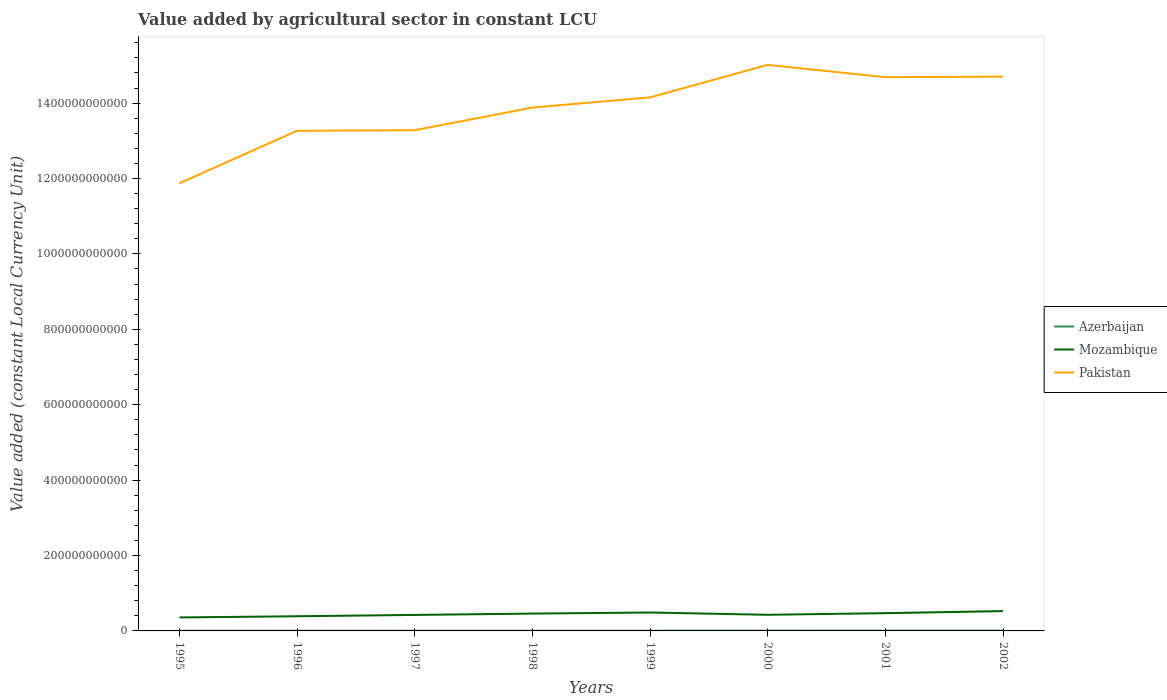How many different coloured lines are there?
Ensure brevity in your answer.  3. Does the line corresponding to Mozambique intersect with the line corresponding to Pakistan?
Give a very brief answer. No. Is the number of lines equal to the number of legend labels?
Give a very brief answer. Yes. Across all years, what is the maximum value added by agricultural sector in Azerbaijan?
Keep it short and to the point. 5.58e+08. What is the total value added by agricultural sector in Pakistan in the graph?
Your answer should be very brief. -1.42e+11. What is the difference between the highest and the second highest value added by agricultural sector in Mozambique?
Your answer should be very brief. 1.68e+1. Is the value added by agricultural sector in Mozambique strictly greater than the value added by agricultural sector in Pakistan over the years?
Give a very brief answer. Yes. How many lines are there?
Ensure brevity in your answer.  3. What is the difference between two consecutive major ticks on the Y-axis?
Make the answer very short. 2.00e+11. Are the values on the major ticks of Y-axis written in scientific E-notation?
Your answer should be compact. No. Does the graph contain any zero values?
Provide a short and direct response. No. Does the graph contain grids?
Your answer should be very brief. No. How are the legend labels stacked?
Your answer should be very brief. Vertical. What is the title of the graph?
Give a very brief answer. Value added by agricultural sector in constant LCU. Does "Arab World" appear as one of the legend labels in the graph?
Ensure brevity in your answer.  No. What is the label or title of the Y-axis?
Offer a very short reply. Value added (constant Local Currency Unit). What is the Value added (constant Local Currency Unit) of Azerbaijan in 1995?
Provide a succinct answer. 5.82e+08. What is the Value added (constant Local Currency Unit) in Mozambique in 1995?
Offer a very short reply. 3.58e+1. What is the Value added (constant Local Currency Unit) in Pakistan in 1995?
Provide a short and direct response. 1.19e+12. What is the Value added (constant Local Currency Unit) in Azerbaijan in 1996?
Give a very brief answer. 5.99e+08. What is the Value added (constant Local Currency Unit) of Mozambique in 1996?
Make the answer very short. 3.89e+1. What is the Value added (constant Local Currency Unit) in Pakistan in 1996?
Provide a short and direct response. 1.33e+12. What is the Value added (constant Local Currency Unit) in Azerbaijan in 1997?
Offer a terse response. 5.58e+08. What is the Value added (constant Local Currency Unit) of Mozambique in 1997?
Ensure brevity in your answer.  4.24e+1. What is the Value added (constant Local Currency Unit) of Pakistan in 1997?
Your response must be concise. 1.33e+12. What is the Value added (constant Local Currency Unit) of Azerbaijan in 1998?
Keep it short and to the point. 5.93e+08. What is the Value added (constant Local Currency Unit) in Mozambique in 1998?
Make the answer very short. 4.60e+1. What is the Value added (constant Local Currency Unit) in Pakistan in 1998?
Make the answer very short. 1.39e+12. What is the Value added (constant Local Currency Unit) in Azerbaijan in 1999?
Offer a very short reply. 6.35e+08. What is the Value added (constant Local Currency Unit) in Mozambique in 1999?
Your answer should be compact. 4.88e+1. What is the Value added (constant Local Currency Unit) in Pakistan in 1999?
Provide a succinct answer. 1.42e+12. What is the Value added (constant Local Currency Unit) in Azerbaijan in 2000?
Make the answer very short. 7.59e+08. What is the Value added (constant Local Currency Unit) of Mozambique in 2000?
Your answer should be very brief. 4.28e+1. What is the Value added (constant Local Currency Unit) of Pakistan in 2000?
Offer a very short reply. 1.50e+12. What is the Value added (constant Local Currency Unit) in Azerbaijan in 2001?
Your answer should be very brief. 8.43e+08. What is the Value added (constant Local Currency Unit) in Mozambique in 2001?
Ensure brevity in your answer.  4.71e+1. What is the Value added (constant Local Currency Unit) of Pakistan in 2001?
Your answer should be very brief. 1.47e+12. What is the Value added (constant Local Currency Unit) of Azerbaijan in 2002?
Offer a very short reply. 8.97e+08. What is the Value added (constant Local Currency Unit) of Mozambique in 2002?
Provide a succinct answer. 5.26e+1. What is the Value added (constant Local Currency Unit) in Pakistan in 2002?
Offer a terse response. 1.47e+12. Across all years, what is the maximum Value added (constant Local Currency Unit) of Azerbaijan?
Provide a succinct answer. 8.97e+08. Across all years, what is the maximum Value added (constant Local Currency Unit) of Mozambique?
Provide a succinct answer. 5.26e+1. Across all years, what is the maximum Value added (constant Local Currency Unit) of Pakistan?
Your answer should be very brief. 1.50e+12. Across all years, what is the minimum Value added (constant Local Currency Unit) in Azerbaijan?
Offer a terse response. 5.58e+08. Across all years, what is the minimum Value added (constant Local Currency Unit) of Mozambique?
Your answer should be very brief. 3.58e+1. Across all years, what is the minimum Value added (constant Local Currency Unit) of Pakistan?
Offer a terse response. 1.19e+12. What is the total Value added (constant Local Currency Unit) of Azerbaijan in the graph?
Offer a terse response. 5.47e+09. What is the total Value added (constant Local Currency Unit) of Mozambique in the graph?
Ensure brevity in your answer.  3.54e+11. What is the total Value added (constant Local Currency Unit) of Pakistan in the graph?
Give a very brief answer. 1.11e+13. What is the difference between the Value added (constant Local Currency Unit) in Azerbaijan in 1995 and that in 1996?
Keep it short and to the point. -1.75e+07. What is the difference between the Value added (constant Local Currency Unit) of Mozambique in 1995 and that in 1996?
Your answer should be very brief. -3.13e+09. What is the difference between the Value added (constant Local Currency Unit) of Pakistan in 1995 and that in 1996?
Give a very brief answer. -1.39e+11. What is the difference between the Value added (constant Local Currency Unit) in Azerbaijan in 1995 and that in 1997?
Give a very brief answer. 2.39e+07. What is the difference between the Value added (constant Local Currency Unit) in Mozambique in 1995 and that in 1997?
Offer a very short reply. -6.67e+09. What is the difference between the Value added (constant Local Currency Unit) in Pakistan in 1995 and that in 1997?
Your answer should be very brief. -1.41e+11. What is the difference between the Value added (constant Local Currency Unit) in Azerbaijan in 1995 and that in 1998?
Keep it short and to the point. -1.07e+07. What is the difference between the Value added (constant Local Currency Unit) in Mozambique in 1995 and that in 1998?
Make the answer very short. -1.02e+1. What is the difference between the Value added (constant Local Currency Unit) of Pakistan in 1995 and that in 1998?
Your answer should be compact. -2.01e+11. What is the difference between the Value added (constant Local Currency Unit) of Azerbaijan in 1995 and that in 1999?
Give a very brief answer. -5.28e+07. What is the difference between the Value added (constant Local Currency Unit) in Mozambique in 1995 and that in 1999?
Give a very brief answer. -1.31e+1. What is the difference between the Value added (constant Local Currency Unit) in Pakistan in 1995 and that in 1999?
Give a very brief answer. -2.28e+11. What is the difference between the Value added (constant Local Currency Unit) in Azerbaijan in 1995 and that in 2000?
Make the answer very short. -1.77e+08. What is the difference between the Value added (constant Local Currency Unit) in Mozambique in 1995 and that in 2000?
Ensure brevity in your answer.  -7.01e+09. What is the difference between the Value added (constant Local Currency Unit) of Pakistan in 1995 and that in 2000?
Make the answer very short. -3.14e+11. What is the difference between the Value added (constant Local Currency Unit) in Azerbaijan in 1995 and that in 2001?
Make the answer very short. -2.61e+08. What is the difference between the Value added (constant Local Currency Unit) of Mozambique in 1995 and that in 2001?
Give a very brief answer. -1.13e+1. What is the difference between the Value added (constant Local Currency Unit) of Pakistan in 1995 and that in 2001?
Make the answer very short. -2.81e+11. What is the difference between the Value added (constant Local Currency Unit) of Azerbaijan in 1995 and that in 2002?
Your answer should be very brief. -3.15e+08. What is the difference between the Value added (constant Local Currency Unit) of Mozambique in 1995 and that in 2002?
Your answer should be compact. -1.68e+1. What is the difference between the Value added (constant Local Currency Unit) of Pakistan in 1995 and that in 2002?
Offer a very short reply. -2.83e+11. What is the difference between the Value added (constant Local Currency Unit) in Azerbaijan in 1996 and that in 1997?
Offer a terse response. 4.14e+07. What is the difference between the Value added (constant Local Currency Unit) of Mozambique in 1996 and that in 1997?
Make the answer very short. -3.54e+09. What is the difference between the Value added (constant Local Currency Unit) of Pakistan in 1996 and that in 1997?
Your response must be concise. -1.64e+09. What is the difference between the Value added (constant Local Currency Unit) in Azerbaijan in 1996 and that in 1998?
Give a very brief answer. 6.76e+06. What is the difference between the Value added (constant Local Currency Unit) of Mozambique in 1996 and that in 1998?
Provide a short and direct response. -7.11e+09. What is the difference between the Value added (constant Local Currency Unit) in Pakistan in 1996 and that in 1998?
Offer a terse response. -6.16e+1. What is the difference between the Value added (constant Local Currency Unit) in Azerbaijan in 1996 and that in 1999?
Provide a short and direct response. -3.53e+07. What is the difference between the Value added (constant Local Currency Unit) of Mozambique in 1996 and that in 1999?
Make the answer very short. -9.93e+09. What is the difference between the Value added (constant Local Currency Unit) of Pakistan in 1996 and that in 1999?
Your response must be concise. -8.87e+1. What is the difference between the Value added (constant Local Currency Unit) in Azerbaijan in 1996 and that in 2000?
Provide a succinct answer. -1.60e+08. What is the difference between the Value added (constant Local Currency Unit) of Mozambique in 1996 and that in 2000?
Give a very brief answer. -3.88e+09. What is the difference between the Value added (constant Local Currency Unit) of Pakistan in 1996 and that in 2000?
Offer a terse response. -1.75e+11. What is the difference between the Value added (constant Local Currency Unit) of Azerbaijan in 1996 and that in 2001?
Offer a very short reply. -2.44e+08. What is the difference between the Value added (constant Local Currency Unit) in Mozambique in 1996 and that in 2001?
Make the answer very short. -8.22e+09. What is the difference between the Value added (constant Local Currency Unit) in Pakistan in 1996 and that in 2001?
Make the answer very short. -1.42e+11. What is the difference between the Value added (constant Local Currency Unit) of Azerbaijan in 1996 and that in 2002?
Your answer should be very brief. -2.98e+08. What is the difference between the Value added (constant Local Currency Unit) of Mozambique in 1996 and that in 2002?
Ensure brevity in your answer.  -1.37e+1. What is the difference between the Value added (constant Local Currency Unit) of Pakistan in 1996 and that in 2002?
Offer a very short reply. -1.44e+11. What is the difference between the Value added (constant Local Currency Unit) in Azerbaijan in 1997 and that in 1998?
Keep it short and to the point. -3.46e+07. What is the difference between the Value added (constant Local Currency Unit) in Mozambique in 1997 and that in 1998?
Your answer should be compact. -3.57e+09. What is the difference between the Value added (constant Local Currency Unit) in Pakistan in 1997 and that in 1998?
Give a very brief answer. -6.00e+1. What is the difference between the Value added (constant Local Currency Unit) in Azerbaijan in 1997 and that in 1999?
Keep it short and to the point. -7.67e+07. What is the difference between the Value added (constant Local Currency Unit) in Mozambique in 1997 and that in 1999?
Ensure brevity in your answer.  -6.39e+09. What is the difference between the Value added (constant Local Currency Unit) in Pakistan in 1997 and that in 1999?
Your answer should be very brief. -8.71e+1. What is the difference between the Value added (constant Local Currency Unit) in Azerbaijan in 1997 and that in 2000?
Give a very brief answer. -2.01e+08. What is the difference between the Value added (constant Local Currency Unit) of Mozambique in 1997 and that in 2000?
Provide a succinct answer. -3.44e+08. What is the difference between the Value added (constant Local Currency Unit) of Pakistan in 1997 and that in 2000?
Keep it short and to the point. -1.73e+11. What is the difference between the Value added (constant Local Currency Unit) of Azerbaijan in 1997 and that in 2001?
Ensure brevity in your answer.  -2.85e+08. What is the difference between the Value added (constant Local Currency Unit) of Mozambique in 1997 and that in 2001?
Ensure brevity in your answer.  -4.68e+09. What is the difference between the Value added (constant Local Currency Unit) of Pakistan in 1997 and that in 2001?
Provide a succinct answer. -1.41e+11. What is the difference between the Value added (constant Local Currency Unit) of Azerbaijan in 1997 and that in 2002?
Provide a succinct answer. -3.39e+08. What is the difference between the Value added (constant Local Currency Unit) in Mozambique in 1997 and that in 2002?
Keep it short and to the point. -1.01e+1. What is the difference between the Value added (constant Local Currency Unit) in Pakistan in 1997 and that in 2002?
Provide a short and direct response. -1.42e+11. What is the difference between the Value added (constant Local Currency Unit) in Azerbaijan in 1998 and that in 1999?
Give a very brief answer. -4.21e+07. What is the difference between the Value added (constant Local Currency Unit) of Mozambique in 1998 and that in 1999?
Offer a terse response. -2.82e+09. What is the difference between the Value added (constant Local Currency Unit) of Pakistan in 1998 and that in 1999?
Keep it short and to the point. -2.71e+1. What is the difference between the Value added (constant Local Currency Unit) of Azerbaijan in 1998 and that in 2000?
Your response must be concise. -1.66e+08. What is the difference between the Value added (constant Local Currency Unit) of Mozambique in 1998 and that in 2000?
Your response must be concise. 3.23e+09. What is the difference between the Value added (constant Local Currency Unit) of Pakistan in 1998 and that in 2000?
Provide a succinct answer. -1.13e+11. What is the difference between the Value added (constant Local Currency Unit) of Azerbaijan in 1998 and that in 2001?
Ensure brevity in your answer.  -2.51e+08. What is the difference between the Value added (constant Local Currency Unit) of Mozambique in 1998 and that in 2001?
Your response must be concise. -1.11e+09. What is the difference between the Value added (constant Local Currency Unit) of Pakistan in 1998 and that in 2001?
Ensure brevity in your answer.  -8.06e+1. What is the difference between the Value added (constant Local Currency Unit) in Azerbaijan in 1998 and that in 2002?
Ensure brevity in your answer.  -3.05e+08. What is the difference between the Value added (constant Local Currency Unit) of Mozambique in 1998 and that in 2002?
Provide a short and direct response. -6.56e+09. What is the difference between the Value added (constant Local Currency Unit) in Pakistan in 1998 and that in 2002?
Give a very brief answer. -8.21e+1. What is the difference between the Value added (constant Local Currency Unit) in Azerbaijan in 1999 and that in 2000?
Give a very brief answer. -1.24e+08. What is the difference between the Value added (constant Local Currency Unit) of Mozambique in 1999 and that in 2000?
Offer a terse response. 6.05e+09. What is the difference between the Value added (constant Local Currency Unit) of Pakistan in 1999 and that in 2000?
Offer a terse response. -8.62e+1. What is the difference between the Value added (constant Local Currency Unit) of Azerbaijan in 1999 and that in 2001?
Make the answer very short. -2.09e+08. What is the difference between the Value added (constant Local Currency Unit) in Mozambique in 1999 and that in 2001?
Keep it short and to the point. 1.71e+09. What is the difference between the Value added (constant Local Currency Unit) in Pakistan in 1999 and that in 2001?
Ensure brevity in your answer.  -5.35e+1. What is the difference between the Value added (constant Local Currency Unit) in Azerbaijan in 1999 and that in 2002?
Provide a succinct answer. -2.62e+08. What is the difference between the Value added (constant Local Currency Unit) of Mozambique in 1999 and that in 2002?
Your response must be concise. -3.74e+09. What is the difference between the Value added (constant Local Currency Unit) in Pakistan in 1999 and that in 2002?
Your response must be concise. -5.51e+1. What is the difference between the Value added (constant Local Currency Unit) in Azerbaijan in 2000 and that in 2001?
Offer a very short reply. -8.42e+07. What is the difference between the Value added (constant Local Currency Unit) of Mozambique in 2000 and that in 2001?
Make the answer very short. -4.33e+09. What is the difference between the Value added (constant Local Currency Unit) of Pakistan in 2000 and that in 2001?
Provide a short and direct response. 3.27e+1. What is the difference between the Value added (constant Local Currency Unit) in Azerbaijan in 2000 and that in 2002?
Provide a succinct answer. -1.38e+08. What is the difference between the Value added (constant Local Currency Unit) of Mozambique in 2000 and that in 2002?
Your answer should be compact. -9.79e+09. What is the difference between the Value added (constant Local Currency Unit) in Pakistan in 2000 and that in 2002?
Give a very brief answer. 3.12e+1. What is the difference between the Value added (constant Local Currency Unit) in Azerbaijan in 2001 and that in 2002?
Provide a succinct answer. -5.40e+07. What is the difference between the Value added (constant Local Currency Unit) in Mozambique in 2001 and that in 2002?
Provide a short and direct response. -5.46e+09. What is the difference between the Value added (constant Local Currency Unit) in Pakistan in 2001 and that in 2002?
Offer a very short reply. -1.52e+09. What is the difference between the Value added (constant Local Currency Unit) in Azerbaijan in 1995 and the Value added (constant Local Currency Unit) in Mozambique in 1996?
Ensure brevity in your answer.  -3.83e+1. What is the difference between the Value added (constant Local Currency Unit) of Azerbaijan in 1995 and the Value added (constant Local Currency Unit) of Pakistan in 1996?
Provide a succinct answer. -1.33e+12. What is the difference between the Value added (constant Local Currency Unit) in Mozambique in 1995 and the Value added (constant Local Currency Unit) in Pakistan in 1996?
Give a very brief answer. -1.29e+12. What is the difference between the Value added (constant Local Currency Unit) in Azerbaijan in 1995 and the Value added (constant Local Currency Unit) in Mozambique in 1997?
Your response must be concise. -4.19e+1. What is the difference between the Value added (constant Local Currency Unit) of Azerbaijan in 1995 and the Value added (constant Local Currency Unit) of Pakistan in 1997?
Your response must be concise. -1.33e+12. What is the difference between the Value added (constant Local Currency Unit) of Mozambique in 1995 and the Value added (constant Local Currency Unit) of Pakistan in 1997?
Give a very brief answer. -1.29e+12. What is the difference between the Value added (constant Local Currency Unit) in Azerbaijan in 1995 and the Value added (constant Local Currency Unit) in Mozambique in 1998?
Your answer should be compact. -4.54e+1. What is the difference between the Value added (constant Local Currency Unit) of Azerbaijan in 1995 and the Value added (constant Local Currency Unit) of Pakistan in 1998?
Make the answer very short. -1.39e+12. What is the difference between the Value added (constant Local Currency Unit) of Mozambique in 1995 and the Value added (constant Local Currency Unit) of Pakistan in 1998?
Offer a very short reply. -1.35e+12. What is the difference between the Value added (constant Local Currency Unit) of Azerbaijan in 1995 and the Value added (constant Local Currency Unit) of Mozambique in 1999?
Your response must be concise. -4.83e+1. What is the difference between the Value added (constant Local Currency Unit) of Azerbaijan in 1995 and the Value added (constant Local Currency Unit) of Pakistan in 1999?
Provide a succinct answer. -1.41e+12. What is the difference between the Value added (constant Local Currency Unit) in Mozambique in 1995 and the Value added (constant Local Currency Unit) in Pakistan in 1999?
Offer a terse response. -1.38e+12. What is the difference between the Value added (constant Local Currency Unit) in Azerbaijan in 1995 and the Value added (constant Local Currency Unit) in Mozambique in 2000?
Provide a succinct answer. -4.22e+1. What is the difference between the Value added (constant Local Currency Unit) of Azerbaijan in 1995 and the Value added (constant Local Currency Unit) of Pakistan in 2000?
Your answer should be compact. -1.50e+12. What is the difference between the Value added (constant Local Currency Unit) in Mozambique in 1995 and the Value added (constant Local Currency Unit) in Pakistan in 2000?
Your response must be concise. -1.47e+12. What is the difference between the Value added (constant Local Currency Unit) of Azerbaijan in 1995 and the Value added (constant Local Currency Unit) of Mozambique in 2001?
Your response must be concise. -4.65e+1. What is the difference between the Value added (constant Local Currency Unit) in Azerbaijan in 1995 and the Value added (constant Local Currency Unit) in Pakistan in 2001?
Your answer should be compact. -1.47e+12. What is the difference between the Value added (constant Local Currency Unit) in Mozambique in 1995 and the Value added (constant Local Currency Unit) in Pakistan in 2001?
Your answer should be very brief. -1.43e+12. What is the difference between the Value added (constant Local Currency Unit) in Azerbaijan in 1995 and the Value added (constant Local Currency Unit) in Mozambique in 2002?
Keep it short and to the point. -5.20e+1. What is the difference between the Value added (constant Local Currency Unit) of Azerbaijan in 1995 and the Value added (constant Local Currency Unit) of Pakistan in 2002?
Ensure brevity in your answer.  -1.47e+12. What is the difference between the Value added (constant Local Currency Unit) of Mozambique in 1995 and the Value added (constant Local Currency Unit) of Pakistan in 2002?
Ensure brevity in your answer.  -1.43e+12. What is the difference between the Value added (constant Local Currency Unit) in Azerbaijan in 1996 and the Value added (constant Local Currency Unit) in Mozambique in 1997?
Your response must be concise. -4.18e+1. What is the difference between the Value added (constant Local Currency Unit) in Azerbaijan in 1996 and the Value added (constant Local Currency Unit) in Pakistan in 1997?
Provide a succinct answer. -1.33e+12. What is the difference between the Value added (constant Local Currency Unit) of Mozambique in 1996 and the Value added (constant Local Currency Unit) of Pakistan in 1997?
Your answer should be very brief. -1.29e+12. What is the difference between the Value added (constant Local Currency Unit) in Azerbaijan in 1996 and the Value added (constant Local Currency Unit) in Mozambique in 1998?
Provide a short and direct response. -4.54e+1. What is the difference between the Value added (constant Local Currency Unit) of Azerbaijan in 1996 and the Value added (constant Local Currency Unit) of Pakistan in 1998?
Give a very brief answer. -1.39e+12. What is the difference between the Value added (constant Local Currency Unit) in Mozambique in 1996 and the Value added (constant Local Currency Unit) in Pakistan in 1998?
Offer a very short reply. -1.35e+12. What is the difference between the Value added (constant Local Currency Unit) of Azerbaijan in 1996 and the Value added (constant Local Currency Unit) of Mozambique in 1999?
Offer a very short reply. -4.82e+1. What is the difference between the Value added (constant Local Currency Unit) of Azerbaijan in 1996 and the Value added (constant Local Currency Unit) of Pakistan in 1999?
Give a very brief answer. -1.41e+12. What is the difference between the Value added (constant Local Currency Unit) in Mozambique in 1996 and the Value added (constant Local Currency Unit) in Pakistan in 1999?
Give a very brief answer. -1.38e+12. What is the difference between the Value added (constant Local Currency Unit) of Azerbaijan in 1996 and the Value added (constant Local Currency Unit) of Mozambique in 2000?
Your response must be concise. -4.22e+1. What is the difference between the Value added (constant Local Currency Unit) in Azerbaijan in 1996 and the Value added (constant Local Currency Unit) in Pakistan in 2000?
Your answer should be compact. -1.50e+12. What is the difference between the Value added (constant Local Currency Unit) of Mozambique in 1996 and the Value added (constant Local Currency Unit) of Pakistan in 2000?
Your response must be concise. -1.46e+12. What is the difference between the Value added (constant Local Currency Unit) in Azerbaijan in 1996 and the Value added (constant Local Currency Unit) in Mozambique in 2001?
Provide a short and direct response. -4.65e+1. What is the difference between the Value added (constant Local Currency Unit) of Azerbaijan in 1996 and the Value added (constant Local Currency Unit) of Pakistan in 2001?
Your answer should be compact. -1.47e+12. What is the difference between the Value added (constant Local Currency Unit) in Mozambique in 1996 and the Value added (constant Local Currency Unit) in Pakistan in 2001?
Ensure brevity in your answer.  -1.43e+12. What is the difference between the Value added (constant Local Currency Unit) in Azerbaijan in 1996 and the Value added (constant Local Currency Unit) in Mozambique in 2002?
Your response must be concise. -5.20e+1. What is the difference between the Value added (constant Local Currency Unit) of Azerbaijan in 1996 and the Value added (constant Local Currency Unit) of Pakistan in 2002?
Your answer should be compact. -1.47e+12. What is the difference between the Value added (constant Local Currency Unit) in Mozambique in 1996 and the Value added (constant Local Currency Unit) in Pakistan in 2002?
Give a very brief answer. -1.43e+12. What is the difference between the Value added (constant Local Currency Unit) in Azerbaijan in 1997 and the Value added (constant Local Currency Unit) in Mozambique in 1998?
Provide a short and direct response. -4.55e+1. What is the difference between the Value added (constant Local Currency Unit) of Azerbaijan in 1997 and the Value added (constant Local Currency Unit) of Pakistan in 1998?
Offer a terse response. -1.39e+12. What is the difference between the Value added (constant Local Currency Unit) in Mozambique in 1997 and the Value added (constant Local Currency Unit) in Pakistan in 1998?
Ensure brevity in your answer.  -1.35e+12. What is the difference between the Value added (constant Local Currency Unit) in Azerbaijan in 1997 and the Value added (constant Local Currency Unit) in Mozambique in 1999?
Provide a succinct answer. -4.83e+1. What is the difference between the Value added (constant Local Currency Unit) of Azerbaijan in 1997 and the Value added (constant Local Currency Unit) of Pakistan in 1999?
Offer a terse response. -1.41e+12. What is the difference between the Value added (constant Local Currency Unit) in Mozambique in 1997 and the Value added (constant Local Currency Unit) in Pakistan in 1999?
Make the answer very short. -1.37e+12. What is the difference between the Value added (constant Local Currency Unit) of Azerbaijan in 1997 and the Value added (constant Local Currency Unit) of Mozambique in 2000?
Make the answer very short. -4.22e+1. What is the difference between the Value added (constant Local Currency Unit) of Azerbaijan in 1997 and the Value added (constant Local Currency Unit) of Pakistan in 2000?
Your answer should be very brief. -1.50e+12. What is the difference between the Value added (constant Local Currency Unit) in Mozambique in 1997 and the Value added (constant Local Currency Unit) in Pakistan in 2000?
Provide a short and direct response. -1.46e+12. What is the difference between the Value added (constant Local Currency Unit) of Azerbaijan in 1997 and the Value added (constant Local Currency Unit) of Mozambique in 2001?
Ensure brevity in your answer.  -4.66e+1. What is the difference between the Value added (constant Local Currency Unit) in Azerbaijan in 1997 and the Value added (constant Local Currency Unit) in Pakistan in 2001?
Your answer should be compact. -1.47e+12. What is the difference between the Value added (constant Local Currency Unit) of Mozambique in 1997 and the Value added (constant Local Currency Unit) of Pakistan in 2001?
Make the answer very short. -1.43e+12. What is the difference between the Value added (constant Local Currency Unit) of Azerbaijan in 1997 and the Value added (constant Local Currency Unit) of Mozambique in 2002?
Your response must be concise. -5.20e+1. What is the difference between the Value added (constant Local Currency Unit) in Azerbaijan in 1997 and the Value added (constant Local Currency Unit) in Pakistan in 2002?
Offer a very short reply. -1.47e+12. What is the difference between the Value added (constant Local Currency Unit) in Mozambique in 1997 and the Value added (constant Local Currency Unit) in Pakistan in 2002?
Provide a short and direct response. -1.43e+12. What is the difference between the Value added (constant Local Currency Unit) in Azerbaijan in 1998 and the Value added (constant Local Currency Unit) in Mozambique in 1999?
Your answer should be compact. -4.82e+1. What is the difference between the Value added (constant Local Currency Unit) in Azerbaijan in 1998 and the Value added (constant Local Currency Unit) in Pakistan in 1999?
Give a very brief answer. -1.41e+12. What is the difference between the Value added (constant Local Currency Unit) in Mozambique in 1998 and the Value added (constant Local Currency Unit) in Pakistan in 1999?
Keep it short and to the point. -1.37e+12. What is the difference between the Value added (constant Local Currency Unit) in Azerbaijan in 1998 and the Value added (constant Local Currency Unit) in Mozambique in 2000?
Keep it short and to the point. -4.22e+1. What is the difference between the Value added (constant Local Currency Unit) of Azerbaijan in 1998 and the Value added (constant Local Currency Unit) of Pakistan in 2000?
Offer a terse response. -1.50e+12. What is the difference between the Value added (constant Local Currency Unit) in Mozambique in 1998 and the Value added (constant Local Currency Unit) in Pakistan in 2000?
Offer a terse response. -1.46e+12. What is the difference between the Value added (constant Local Currency Unit) in Azerbaijan in 1998 and the Value added (constant Local Currency Unit) in Mozambique in 2001?
Give a very brief answer. -4.65e+1. What is the difference between the Value added (constant Local Currency Unit) in Azerbaijan in 1998 and the Value added (constant Local Currency Unit) in Pakistan in 2001?
Your response must be concise. -1.47e+12. What is the difference between the Value added (constant Local Currency Unit) in Mozambique in 1998 and the Value added (constant Local Currency Unit) in Pakistan in 2001?
Offer a very short reply. -1.42e+12. What is the difference between the Value added (constant Local Currency Unit) in Azerbaijan in 1998 and the Value added (constant Local Currency Unit) in Mozambique in 2002?
Make the answer very short. -5.20e+1. What is the difference between the Value added (constant Local Currency Unit) of Azerbaijan in 1998 and the Value added (constant Local Currency Unit) of Pakistan in 2002?
Provide a succinct answer. -1.47e+12. What is the difference between the Value added (constant Local Currency Unit) in Mozambique in 1998 and the Value added (constant Local Currency Unit) in Pakistan in 2002?
Keep it short and to the point. -1.42e+12. What is the difference between the Value added (constant Local Currency Unit) in Azerbaijan in 1999 and the Value added (constant Local Currency Unit) in Mozambique in 2000?
Give a very brief answer. -4.22e+1. What is the difference between the Value added (constant Local Currency Unit) of Azerbaijan in 1999 and the Value added (constant Local Currency Unit) of Pakistan in 2000?
Make the answer very short. -1.50e+12. What is the difference between the Value added (constant Local Currency Unit) in Mozambique in 1999 and the Value added (constant Local Currency Unit) in Pakistan in 2000?
Provide a succinct answer. -1.45e+12. What is the difference between the Value added (constant Local Currency Unit) in Azerbaijan in 1999 and the Value added (constant Local Currency Unit) in Mozambique in 2001?
Make the answer very short. -4.65e+1. What is the difference between the Value added (constant Local Currency Unit) of Azerbaijan in 1999 and the Value added (constant Local Currency Unit) of Pakistan in 2001?
Ensure brevity in your answer.  -1.47e+12. What is the difference between the Value added (constant Local Currency Unit) in Mozambique in 1999 and the Value added (constant Local Currency Unit) in Pakistan in 2001?
Your answer should be compact. -1.42e+12. What is the difference between the Value added (constant Local Currency Unit) of Azerbaijan in 1999 and the Value added (constant Local Currency Unit) of Mozambique in 2002?
Provide a succinct answer. -5.19e+1. What is the difference between the Value added (constant Local Currency Unit) in Azerbaijan in 1999 and the Value added (constant Local Currency Unit) in Pakistan in 2002?
Offer a terse response. -1.47e+12. What is the difference between the Value added (constant Local Currency Unit) in Mozambique in 1999 and the Value added (constant Local Currency Unit) in Pakistan in 2002?
Your response must be concise. -1.42e+12. What is the difference between the Value added (constant Local Currency Unit) in Azerbaijan in 2000 and the Value added (constant Local Currency Unit) in Mozambique in 2001?
Your response must be concise. -4.64e+1. What is the difference between the Value added (constant Local Currency Unit) of Azerbaijan in 2000 and the Value added (constant Local Currency Unit) of Pakistan in 2001?
Ensure brevity in your answer.  -1.47e+12. What is the difference between the Value added (constant Local Currency Unit) of Mozambique in 2000 and the Value added (constant Local Currency Unit) of Pakistan in 2001?
Make the answer very short. -1.43e+12. What is the difference between the Value added (constant Local Currency Unit) of Azerbaijan in 2000 and the Value added (constant Local Currency Unit) of Mozambique in 2002?
Provide a short and direct response. -5.18e+1. What is the difference between the Value added (constant Local Currency Unit) in Azerbaijan in 2000 and the Value added (constant Local Currency Unit) in Pakistan in 2002?
Offer a terse response. -1.47e+12. What is the difference between the Value added (constant Local Currency Unit) in Mozambique in 2000 and the Value added (constant Local Currency Unit) in Pakistan in 2002?
Your answer should be very brief. -1.43e+12. What is the difference between the Value added (constant Local Currency Unit) in Azerbaijan in 2001 and the Value added (constant Local Currency Unit) in Mozambique in 2002?
Ensure brevity in your answer.  -5.17e+1. What is the difference between the Value added (constant Local Currency Unit) in Azerbaijan in 2001 and the Value added (constant Local Currency Unit) in Pakistan in 2002?
Your answer should be very brief. -1.47e+12. What is the difference between the Value added (constant Local Currency Unit) of Mozambique in 2001 and the Value added (constant Local Currency Unit) of Pakistan in 2002?
Keep it short and to the point. -1.42e+12. What is the average Value added (constant Local Currency Unit) in Azerbaijan per year?
Your answer should be very brief. 6.83e+08. What is the average Value added (constant Local Currency Unit) in Mozambique per year?
Your answer should be very brief. 4.43e+1. What is the average Value added (constant Local Currency Unit) of Pakistan per year?
Offer a terse response. 1.39e+12. In the year 1995, what is the difference between the Value added (constant Local Currency Unit) in Azerbaijan and Value added (constant Local Currency Unit) in Mozambique?
Provide a short and direct response. -3.52e+1. In the year 1995, what is the difference between the Value added (constant Local Currency Unit) of Azerbaijan and Value added (constant Local Currency Unit) of Pakistan?
Your answer should be compact. -1.19e+12. In the year 1995, what is the difference between the Value added (constant Local Currency Unit) in Mozambique and Value added (constant Local Currency Unit) in Pakistan?
Your answer should be compact. -1.15e+12. In the year 1996, what is the difference between the Value added (constant Local Currency Unit) of Azerbaijan and Value added (constant Local Currency Unit) of Mozambique?
Your response must be concise. -3.83e+1. In the year 1996, what is the difference between the Value added (constant Local Currency Unit) of Azerbaijan and Value added (constant Local Currency Unit) of Pakistan?
Ensure brevity in your answer.  -1.33e+12. In the year 1996, what is the difference between the Value added (constant Local Currency Unit) of Mozambique and Value added (constant Local Currency Unit) of Pakistan?
Give a very brief answer. -1.29e+12. In the year 1997, what is the difference between the Value added (constant Local Currency Unit) in Azerbaijan and Value added (constant Local Currency Unit) in Mozambique?
Your answer should be very brief. -4.19e+1. In the year 1997, what is the difference between the Value added (constant Local Currency Unit) of Azerbaijan and Value added (constant Local Currency Unit) of Pakistan?
Offer a terse response. -1.33e+12. In the year 1997, what is the difference between the Value added (constant Local Currency Unit) of Mozambique and Value added (constant Local Currency Unit) of Pakistan?
Offer a very short reply. -1.29e+12. In the year 1998, what is the difference between the Value added (constant Local Currency Unit) in Azerbaijan and Value added (constant Local Currency Unit) in Mozambique?
Your response must be concise. -4.54e+1. In the year 1998, what is the difference between the Value added (constant Local Currency Unit) of Azerbaijan and Value added (constant Local Currency Unit) of Pakistan?
Your answer should be very brief. -1.39e+12. In the year 1998, what is the difference between the Value added (constant Local Currency Unit) in Mozambique and Value added (constant Local Currency Unit) in Pakistan?
Your answer should be compact. -1.34e+12. In the year 1999, what is the difference between the Value added (constant Local Currency Unit) of Azerbaijan and Value added (constant Local Currency Unit) of Mozambique?
Your answer should be very brief. -4.82e+1. In the year 1999, what is the difference between the Value added (constant Local Currency Unit) of Azerbaijan and Value added (constant Local Currency Unit) of Pakistan?
Your response must be concise. -1.41e+12. In the year 1999, what is the difference between the Value added (constant Local Currency Unit) in Mozambique and Value added (constant Local Currency Unit) in Pakistan?
Make the answer very short. -1.37e+12. In the year 2000, what is the difference between the Value added (constant Local Currency Unit) in Azerbaijan and Value added (constant Local Currency Unit) in Mozambique?
Offer a very short reply. -4.20e+1. In the year 2000, what is the difference between the Value added (constant Local Currency Unit) of Azerbaijan and Value added (constant Local Currency Unit) of Pakistan?
Give a very brief answer. -1.50e+12. In the year 2000, what is the difference between the Value added (constant Local Currency Unit) in Mozambique and Value added (constant Local Currency Unit) in Pakistan?
Your answer should be very brief. -1.46e+12. In the year 2001, what is the difference between the Value added (constant Local Currency Unit) of Azerbaijan and Value added (constant Local Currency Unit) of Mozambique?
Your answer should be compact. -4.63e+1. In the year 2001, what is the difference between the Value added (constant Local Currency Unit) in Azerbaijan and Value added (constant Local Currency Unit) in Pakistan?
Give a very brief answer. -1.47e+12. In the year 2001, what is the difference between the Value added (constant Local Currency Unit) in Mozambique and Value added (constant Local Currency Unit) in Pakistan?
Provide a short and direct response. -1.42e+12. In the year 2002, what is the difference between the Value added (constant Local Currency Unit) in Azerbaijan and Value added (constant Local Currency Unit) in Mozambique?
Ensure brevity in your answer.  -5.17e+1. In the year 2002, what is the difference between the Value added (constant Local Currency Unit) in Azerbaijan and Value added (constant Local Currency Unit) in Pakistan?
Your response must be concise. -1.47e+12. In the year 2002, what is the difference between the Value added (constant Local Currency Unit) in Mozambique and Value added (constant Local Currency Unit) in Pakistan?
Ensure brevity in your answer.  -1.42e+12. What is the ratio of the Value added (constant Local Currency Unit) of Azerbaijan in 1995 to that in 1996?
Offer a terse response. 0.97. What is the ratio of the Value added (constant Local Currency Unit) of Mozambique in 1995 to that in 1996?
Offer a terse response. 0.92. What is the ratio of the Value added (constant Local Currency Unit) in Pakistan in 1995 to that in 1996?
Offer a terse response. 0.9. What is the ratio of the Value added (constant Local Currency Unit) of Azerbaijan in 1995 to that in 1997?
Your answer should be compact. 1.04. What is the ratio of the Value added (constant Local Currency Unit) in Mozambique in 1995 to that in 1997?
Keep it short and to the point. 0.84. What is the ratio of the Value added (constant Local Currency Unit) of Pakistan in 1995 to that in 1997?
Give a very brief answer. 0.89. What is the ratio of the Value added (constant Local Currency Unit) of Azerbaijan in 1995 to that in 1998?
Give a very brief answer. 0.98. What is the ratio of the Value added (constant Local Currency Unit) in Mozambique in 1995 to that in 1998?
Offer a terse response. 0.78. What is the ratio of the Value added (constant Local Currency Unit) of Pakistan in 1995 to that in 1998?
Provide a short and direct response. 0.86. What is the ratio of the Value added (constant Local Currency Unit) in Azerbaijan in 1995 to that in 1999?
Provide a succinct answer. 0.92. What is the ratio of the Value added (constant Local Currency Unit) in Mozambique in 1995 to that in 1999?
Offer a very short reply. 0.73. What is the ratio of the Value added (constant Local Currency Unit) in Pakistan in 1995 to that in 1999?
Offer a very short reply. 0.84. What is the ratio of the Value added (constant Local Currency Unit) of Azerbaijan in 1995 to that in 2000?
Offer a very short reply. 0.77. What is the ratio of the Value added (constant Local Currency Unit) in Mozambique in 1995 to that in 2000?
Ensure brevity in your answer.  0.84. What is the ratio of the Value added (constant Local Currency Unit) in Pakistan in 1995 to that in 2000?
Offer a terse response. 0.79. What is the ratio of the Value added (constant Local Currency Unit) of Azerbaijan in 1995 to that in 2001?
Make the answer very short. 0.69. What is the ratio of the Value added (constant Local Currency Unit) of Mozambique in 1995 to that in 2001?
Give a very brief answer. 0.76. What is the ratio of the Value added (constant Local Currency Unit) of Pakistan in 1995 to that in 2001?
Offer a terse response. 0.81. What is the ratio of the Value added (constant Local Currency Unit) of Azerbaijan in 1995 to that in 2002?
Your answer should be compact. 0.65. What is the ratio of the Value added (constant Local Currency Unit) of Mozambique in 1995 to that in 2002?
Offer a very short reply. 0.68. What is the ratio of the Value added (constant Local Currency Unit) of Pakistan in 1995 to that in 2002?
Your response must be concise. 0.81. What is the ratio of the Value added (constant Local Currency Unit) of Azerbaijan in 1996 to that in 1997?
Ensure brevity in your answer.  1.07. What is the ratio of the Value added (constant Local Currency Unit) in Pakistan in 1996 to that in 1997?
Make the answer very short. 1. What is the ratio of the Value added (constant Local Currency Unit) of Azerbaijan in 1996 to that in 1998?
Your response must be concise. 1.01. What is the ratio of the Value added (constant Local Currency Unit) in Mozambique in 1996 to that in 1998?
Your answer should be compact. 0.85. What is the ratio of the Value added (constant Local Currency Unit) in Pakistan in 1996 to that in 1998?
Make the answer very short. 0.96. What is the ratio of the Value added (constant Local Currency Unit) of Azerbaijan in 1996 to that in 1999?
Your answer should be very brief. 0.94. What is the ratio of the Value added (constant Local Currency Unit) of Mozambique in 1996 to that in 1999?
Your answer should be very brief. 0.8. What is the ratio of the Value added (constant Local Currency Unit) of Pakistan in 1996 to that in 1999?
Offer a terse response. 0.94. What is the ratio of the Value added (constant Local Currency Unit) in Azerbaijan in 1996 to that in 2000?
Ensure brevity in your answer.  0.79. What is the ratio of the Value added (constant Local Currency Unit) in Mozambique in 1996 to that in 2000?
Your answer should be very brief. 0.91. What is the ratio of the Value added (constant Local Currency Unit) of Pakistan in 1996 to that in 2000?
Keep it short and to the point. 0.88. What is the ratio of the Value added (constant Local Currency Unit) in Azerbaijan in 1996 to that in 2001?
Offer a terse response. 0.71. What is the ratio of the Value added (constant Local Currency Unit) in Mozambique in 1996 to that in 2001?
Offer a very short reply. 0.83. What is the ratio of the Value added (constant Local Currency Unit) of Pakistan in 1996 to that in 2001?
Make the answer very short. 0.9. What is the ratio of the Value added (constant Local Currency Unit) in Azerbaijan in 1996 to that in 2002?
Provide a short and direct response. 0.67. What is the ratio of the Value added (constant Local Currency Unit) in Mozambique in 1996 to that in 2002?
Give a very brief answer. 0.74. What is the ratio of the Value added (constant Local Currency Unit) in Pakistan in 1996 to that in 2002?
Your response must be concise. 0.9. What is the ratio of the Value added (constant Local Currency Unit) of Azerbaijan in 1997 to that in 1998?
Offer a terse response. 0.94. What is the ratio of the Value added (constant Local Currency Unit) of Mozambique in 1997 to that in 1998?
Your response must be concise. 0.92. What is the ratio of the Value added (constant Local Currency Unit) of Pakistan in 1997 to that in 1998?
Provide a succinct answer. 0.96. What is the ratio of the Value added (constant Local Currency Unit) in Azerbaijan in 1997 to that in 1999?
Give a very brief answer. 0.88. What is the ratio of the Value added (constant Local Currency Unit) in Mozambique in 1997 to that in 1999?
Keep it short and to the point. 0.87. What is the ratio of the Value added (constant Local Currency Unit) in Pakistan in 1997 to that in 1999?
Provide a succinct answer. 0.94. What is the ratio of the Value added (constant Local Currency Unit) in Azerbaijan in 1997 to that in 2000?
Your response must be concise. 0.74. What is the ratio of the Value added (constant Local Currency Unit) of Pakistan in 1997 to that in 2000?
Keep it short and to the point. 0.88. What is the ratio of the Value added (constant Local Currency Unit) of Azerbaijan in 1997 to that in 2001?
Offer a very short reply. 0.66. What is the ratio of the Value added (constant Local Currency Unit) in Mozambique in 1997 to that in 2001?
Offer a very short reply. 0.9. What is the ratio of the Value added (constant Local Currency Unit) in Pakistan in 1997 to that in 2001?
Your answer should be very brief. 0.9. What is the ratio of the Value added (constant Local Currency Unit) in Azerbaijan in 1997 to that in 2002?
Ensure brevity in your answer.  0.62. What is the ratio of the Value added (constant Local Currency Unit) in Mozambique in 1997 to that in 2002?
Offer a terse response. 0.81. What is the ratio of the Value added (constant Local Currency Unit) in Pakistan in 1997 to that in 2002?
Provide a short and direct response. 0.9. What is the ratio of the Value added (constant Local Currency Unit) of Azerbaijan in 1998 to that in 1999?
Ensure brevity in your answer.  0.93. What is the ratio of the Value added (constant Local Currency Unit) of Mozambique in 1998 to that in 1999?
Your response must be concise. 0.94. What is the ratio of the Value added (constant Local Currency Unit) of Pakistan in 1998 to that in 1999?
Make the answer very short. 0.98. What is the ratio of the Value added (constant Local Currency Unit) in Azerbaijan in 1998 to that in 2000?
Provide a short and direct response. 0.78. What is the ratio of the Value added (constant Local Currency Unit) in Mozambique in 1998 to that in 2000?
Provide a short and direct response. 1.08. What is the ratio of the Value added (constant Local Currency Unit) of Pakistan in 1998 to that in 2000?
Provide a short and direct response. 0.92. What is the ratio of the Value added (constant Local Currency Unit) in Azerbaijan in 1998 to that in 2001?
Your answer should be compact. 0.7. What is the ratio of the Value added (constant Local Currency Unit) of Mozambique in 1998 to that in 2001?
Your response must be concise. 0.98. What is the ratio of the Value added (constant Local Currency Unit) in Pakistan in 1998 to that in 2001?
Your response must be concise. 0.95. What is the ratio of the Value added (constant Local Currency Unit) of Azerbaijan in 1998 to that in 2002?
Your answer should be very brief. 0.66. What is the ratio of the Value added (constant Local Currency Unit) in Mozambique in 1998 to that in 2002?
Your answer should be compact. 0.88. What is the ratio of the Value added (constant Local Currency Unit) in Pakistan in 1998 to that in 2002?
Your answer should be very brief. 0.94. What is the ratio of the Value added (constant Local Currency Unit) in Azerbaijan in 1999 to that in 2000?
Keep it short and to the point. 0.84. What is the ratio of the Value added (constant Local Currency Unit) of Mozambique in 1999 to that in 2000?
Your answer should be compact. 1.14. What is the ratio of the Value added (constant Local Currency Unit) in Pakistan in 1999 to that in 2000?
Your response must be concise. 0.94. What is the ratio of the Value added (constant Local Currency Unit) of Azerbaijan in 1999 to that in 2001?
Ensure brevity in your answer.  0.75. What is the ratio of the Value added (constant Local Currency Unit) in Mozambique in 1999 to that in 2001?
Offer a very short reply. 1.04. What is the ratio of the Value added (constant Local Currency Unit) of Pakistan in 1999 to that in 2001?
Provide a short and direct response. 0.96. What is the ratio of the Value added (constant Local Currency Unit) in Azerbaijan in 1999 to that in 2002?
Ensure brevity in your answer.  0.71. What is the ratio of the Value added (constant Local Currency Unit) of Mozambique in 1999 to that in 2002?
Your answer should be compact. 0.93. What is the ratio of the Value added (constant Local Currency Unit) of Pakistan in 1999 to that in 2002?
Ensure brevity in your answer.  0.96. What is the ratio of the Value added (constant Local Currency Unit) in Azerbaijan in 2000 to that in 2001?
Offer a terse response. 0.9. What is the ratio of the Value added (constant Local Currency Unit) in Mozambique in 2000 to that in 2001?
Provide a short and direct response. 0.91. What is the ratio of the Value added (constant Local Currency Unit) of Pakistan in 2000 to that in 2001?
Provide a succinct answer. 1.02. What is the ratio of the Value added (constant Local Currency Unit) of Azerbaijan in 2000 to that in 2002?
Give a very brief answer. 0.85. What is the ratio of the Value added (constant Local Currency Unit) of Mozambique in 2000 to that in 2002?
Make the answer very short. 0.81. What is the ratio of the Value added (constant Local Currency Unit) of Pakistan in 2000 to that in 2002?
Keep it short and to the point. 1.02. What is the ratio of the Value added (constant Local Currency Unit) of Azerbaijan in 2001 to that in 2002?
Your answer should be very brief. 0.94. What is the ratio of the Value added (constant Local Currency Unit) of Mozambique in 2001 to that in 2002?
Your response must be concise. 0.9. What is the difference between the highest and the second highest Value added (constant Local Currency Unit) of Azerbaijan?
Give a very brief answer. 5.40e+07. What is the difference between the highest and the second highest Value added (constant Local Currency Unit) in Mozambique?
Offer a very short reply. 3.74e+09. What is the difference between the highest and the second highest Value added (constant Local Currency Unit) in Pakistan?
Your answer should be very brief. 3.12e+1. What is the difference between the highest and the lowest Value added (constant Local Currency Unit) in Azerbaijan?
Give a very brief answer. 3.39e+08. What is the difference between the highest and the lowest Value added (constant Local Currency Unit) of Mozambique?
Offer a terse response. 1.68e+1. What is the difference between the highest and the lowest Value added (constant Local Currency Unit) in Pakistan?
Make the answer very short. 3.14e+11. 